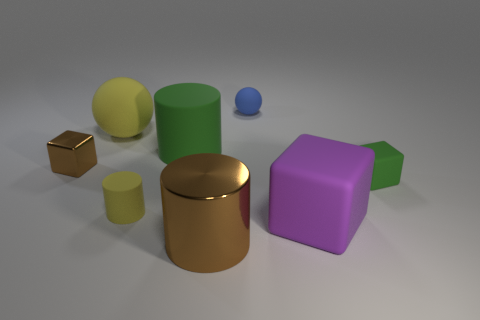What material is the tiny green object?
Offer a terse response. Rubber. There is a matte cylinder that is behind the yellow rubber cylinder; what color is it?
Give a very brief answer. Green. Is the number of large metallic cylinders to the left of the big yellow rubber sphere greater than the number of green matte blocks left of the small brown thing?
Your answer should be very brief. No. How big is the shiny thing on the right side of the green matte thing on the left side of the metallic thing that is on the right side of the metallic block?
Offer a very short reply. Large. Are there any small blocks that have the same color as the small ball?
Your answer should be compact. No. How many rubber things are there?
Keep it short and to the point. 6. There is a yellow thing to the right of the yellow rubber object behind the green cylinder on the right side of the small yellow matte cylinder; what is it made of?
Ensure brevity in your answer.  Rubber. Is there a brown cylinder made of the same material as the big green cylinder?
Make the answer very short. No. Is the material of the small yellow object the same as the large green object?
Offer a terse response. Yes. What number of balls are either brown objects or small matte objects?
Offer a very short reply. 1. 